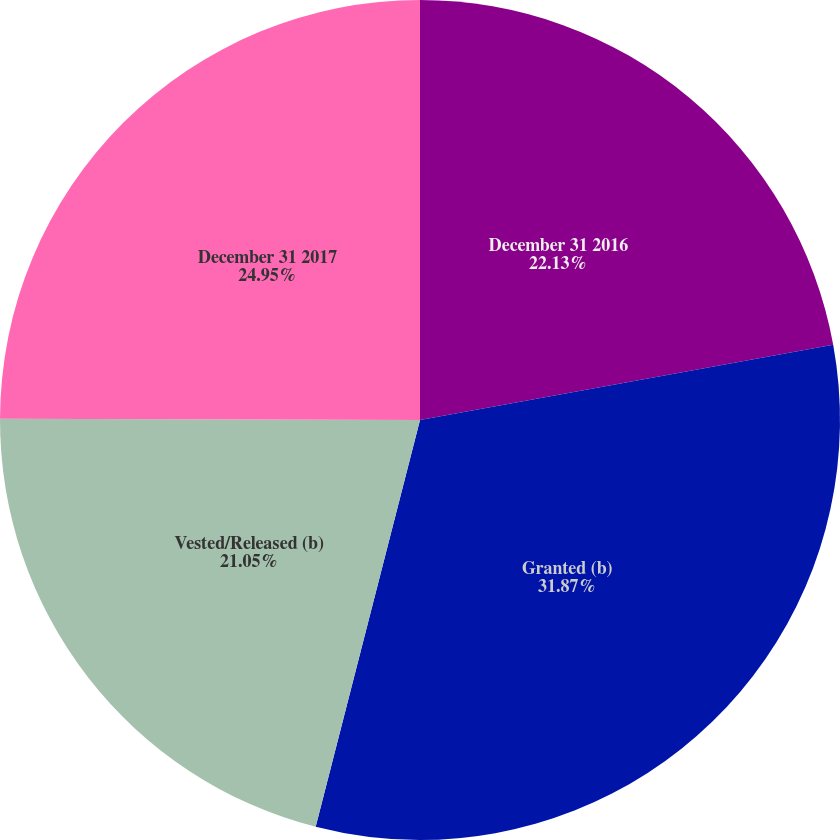Convert chart to OTSL. <chart><loc_0><loc_0><loc_500><loc_500><pie_chart><fcel>December 31 2016<fcel>Granted (b)<fcel>Vested/Released (b)<fcel>December 31 2017<nl><fcel>22.13%<fcel>31.86%<fcel>21.05%<fcel>24.95%<nl></chart> 